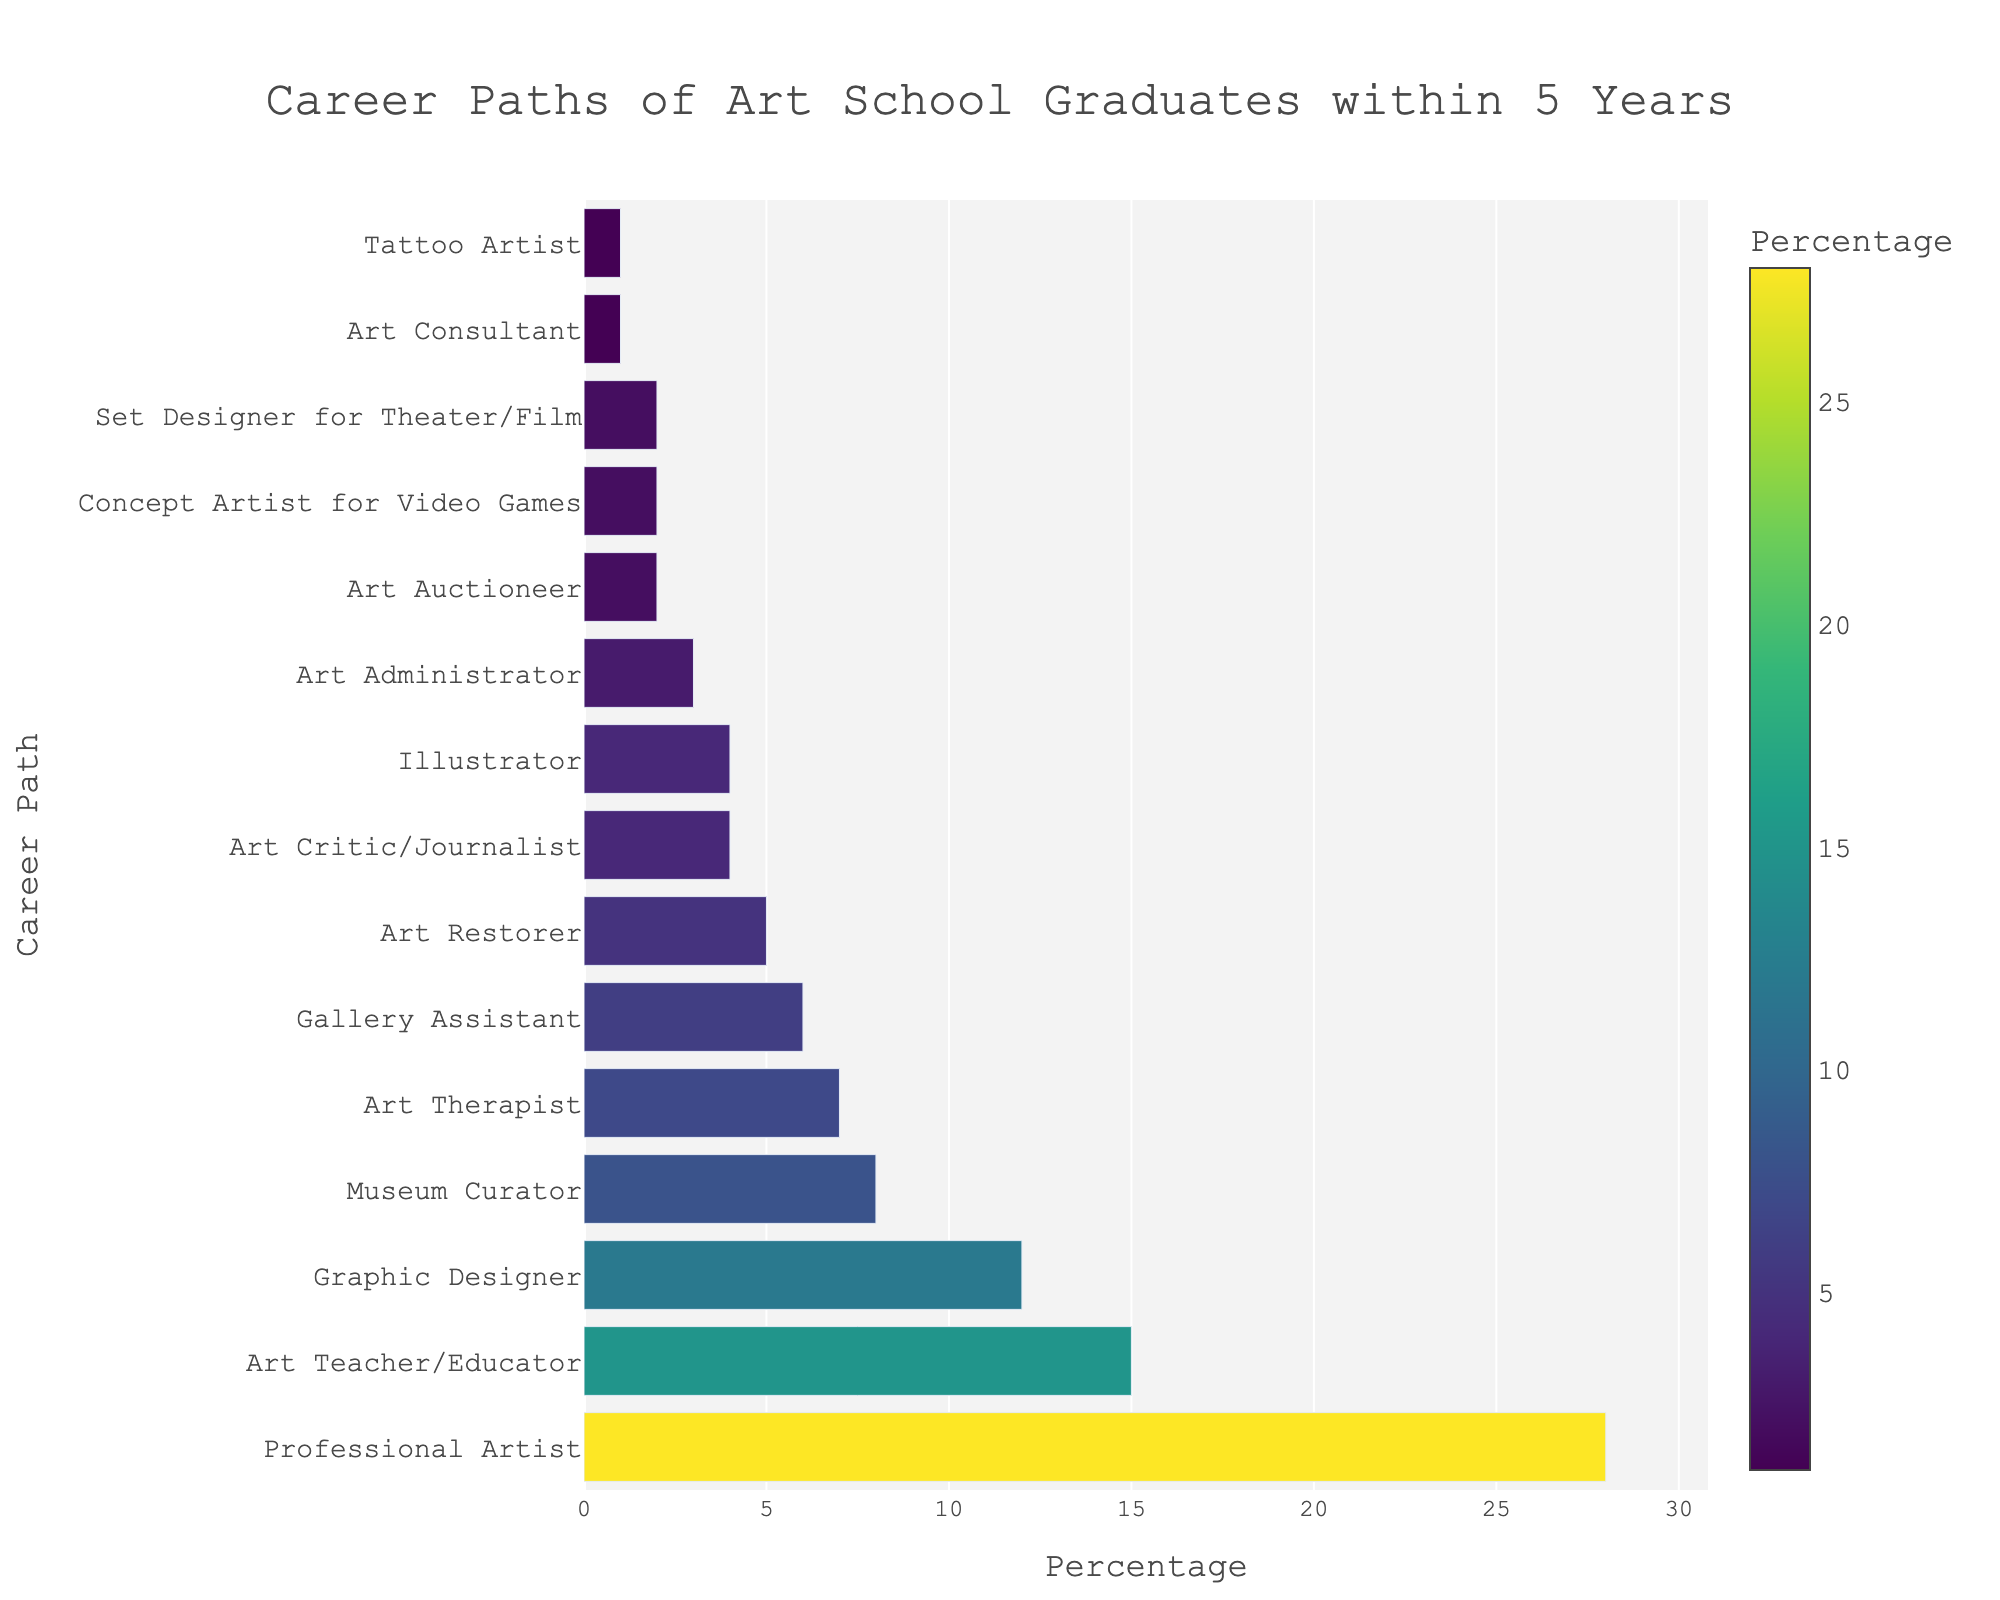What's the most common career path for art school graduates within 5 years of graduation? The bar representing "Professional Artist" is the longest and closest to the highest percentage on the x-axis. This indicates that it is the most common career path.
Answer: Professional Artist Which two career paths have the same percentage of graduates? By visually comparing the lengths of the bars, "Illustrator" and "Art Critic/Journalist" both have bars of identical length corresponding to a percentage of 4%.
Answer: Illustrator and Art Critic/Journalist How does the percentage for "Art Teacher/Educator" compare to "Graphic Designer"? The length of the bar for "Art Teacher/Educator" is longer than that of "Graphic Designer," indicating a higher percentage. Specifically, "Art Teacher/Educator" has 15% and "Graphic Designer" has 12%.
Answer: Art Teacher/Educator has a higher percentage What is the combined percentage of graduates becoming a "Museum Curator" and an "Art Therapist"? Adding the percentages of "Museum Curator" (8%) and "Art Therapist" (7%) results in a total of 15%.
Answer: 15% Which career paths have less than a 5% but more than a 1% share of graduates? By consulting the lengths of the bars, the career paths "Art Restorer" (5%), "Art Critic/Journalist" (4%), "Illustrator" (4%), "Art Administrator" (3%), "Art Auctioneer" (2%), "Concept Artist for Video Games" (2%), and "Set Designer for Theater/Film" (2%) all fall into this range.
Answer: Art Restorer, Art Critic/Journalist, Illustrator, Art Administrator, Art Auctioneer, Concept Artist for Video Games, Set Designer for Theater/Film What's the total percentage of graduates who choose highly specialized careers like "Concept Artist for Video Games," "Set Designer for Theater/Film," and "Tattoo Artist"? By adding the percentages of "Concept Artist for Video Games" (2%), "Set Designer for Theater/Film" (2%), and "Tattoo Artist" (1%), the total is 5%.
Answer: 5% Which career path shows the smallest percentage of art school graduates? The bar for "Art Consultant" and "Tattoo Artist" are the shortest on the graph, indicating the smallest percentages, both at 1%.
Answer: Art Consultant and Tattoo Artist 